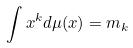Convert formula to latex. <formula><loc_0><loc_0><loc_500><loc_500>\int x ^ { k } d \mu ( x ) = m _ { k }</formula> 